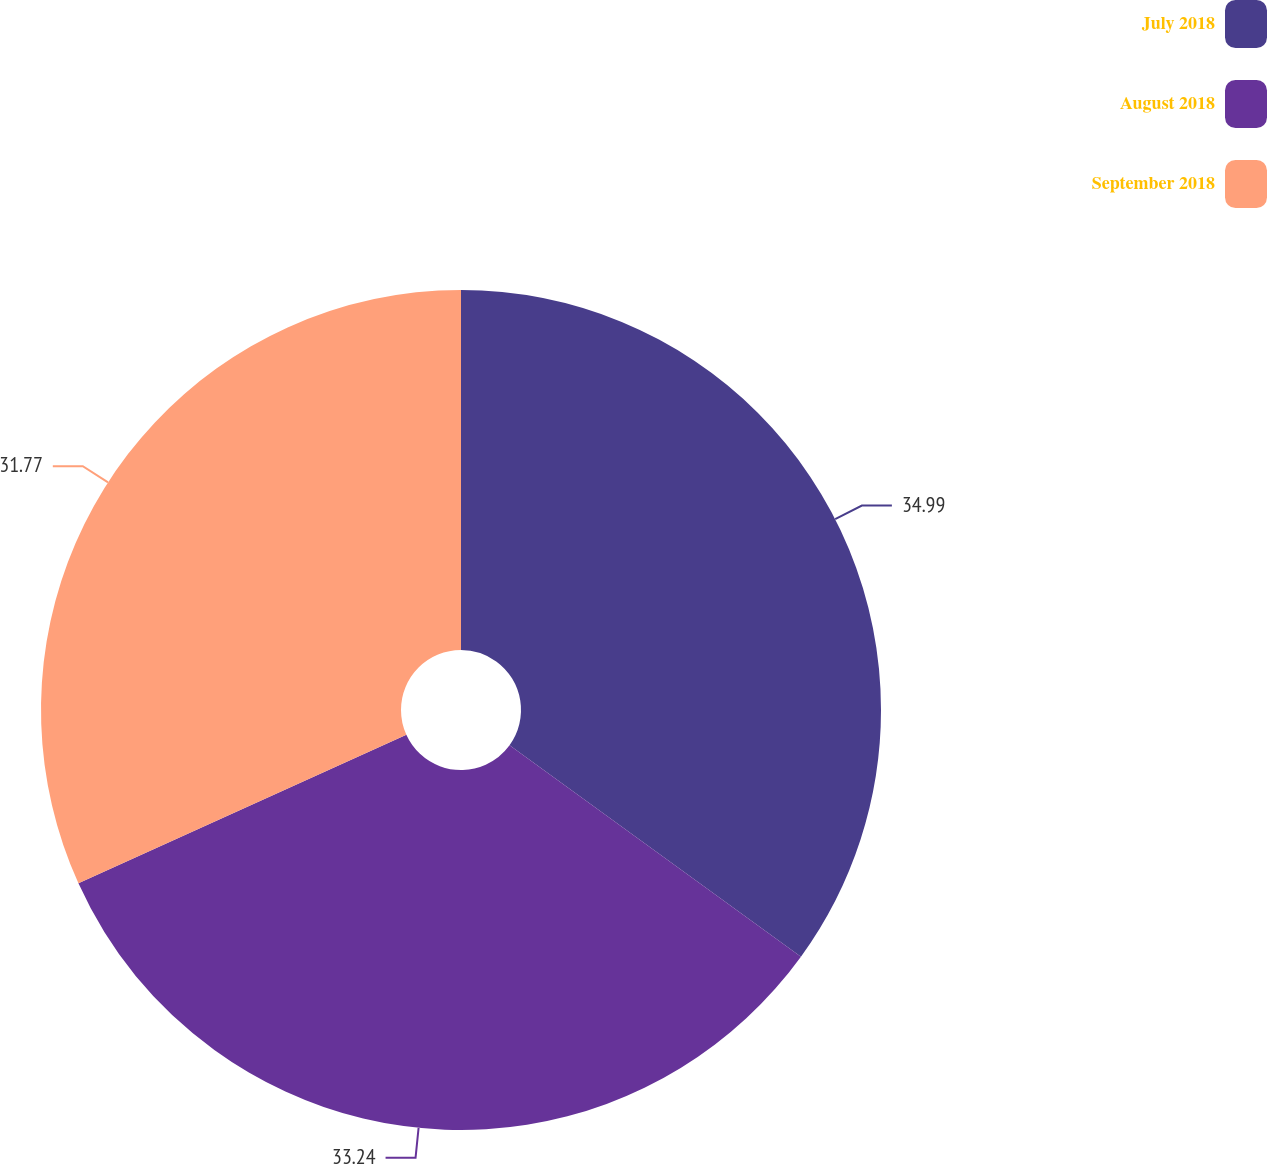Convert chart to OTSL. <chart><loc_0><loc_0><loc_500><loc_500><pie_chart><fcel>July 2018<fcel>August 2018<fcel>September 2018<nl><fcel>34.99%<fcel>33.24%<fcel>31.77%<nl></chart> 